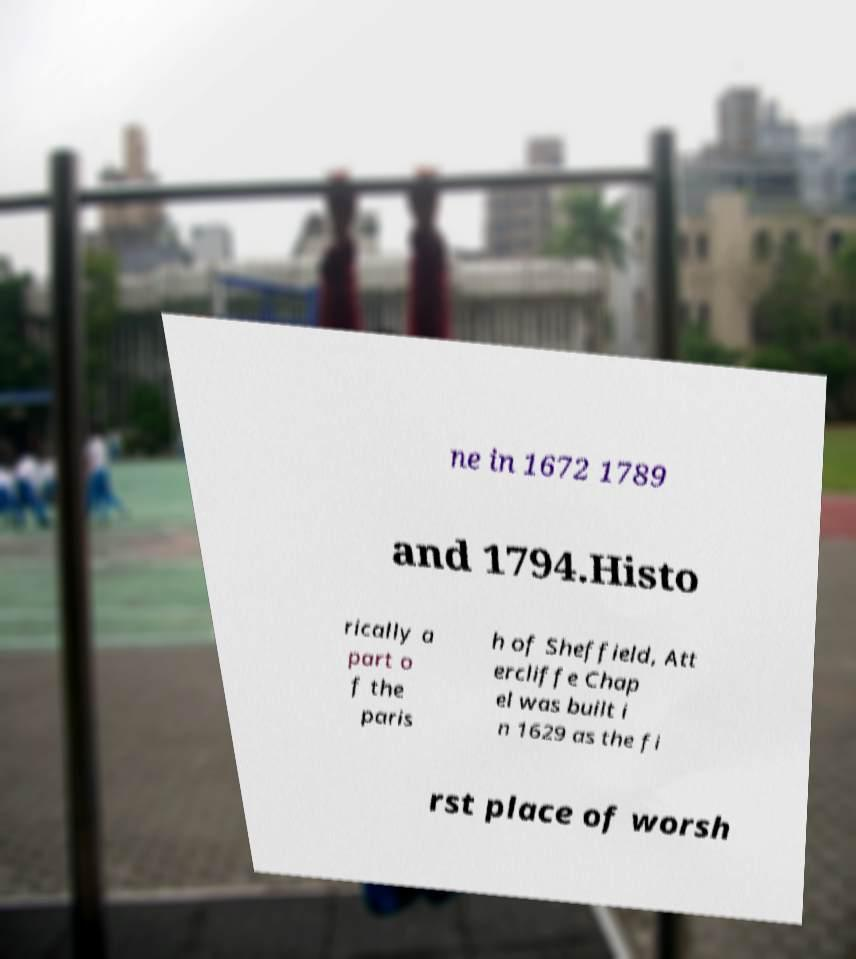Please read and relay the text visible in this image. What does it say? ne in 1672 1789 and 1794.Histo rically a part o f the paris h of Sheffield, Att ercliffe Chap el was built i n 1629 as the fi rst place of worsh 